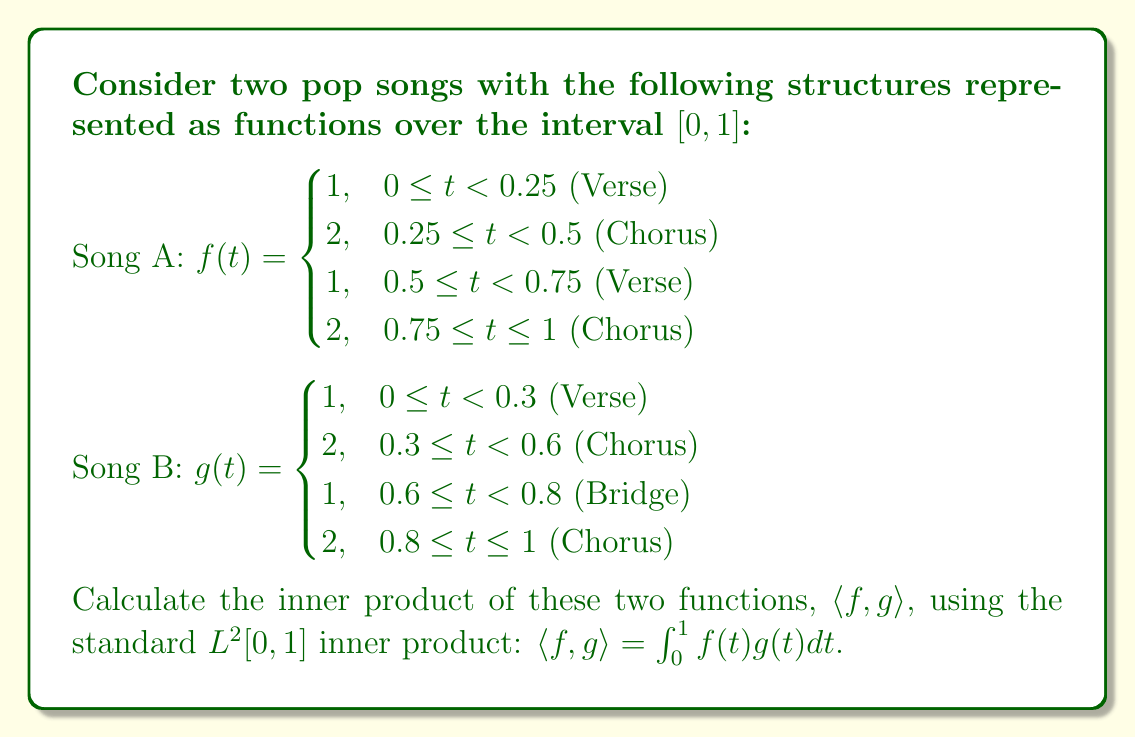Can you solve this math problem? To calculate the inner product of these two functions, we need to multiply them together and integrate over the interval $[0, 1]$. We'll break this down into segments where the functions are constant:

1) For $0 \leq t < 0.25$:
   $f(t) = 1$ and $g(t) = 1$
   $\int_0^{0.25} 1 \cdot 1 dt = 0.25$

2) For $0.25 \leq t < 0.3$:
   $f(t) = 2$ and $g(t) = 1$
   $\int_{0.25}^{0.3} 2 \cdot 1 dt = 2 \cdot 0.05 = 0.1$

3) For $0.3 \leq t < 0.5$:
   $f(t) = 2$ and $g(t) = 2$
   $\int_{0.3}^{0.5} 2 \cdot 2 dt = 4 \cdot 0.2 = 0.8$

4) For $0.5 \leq t < 0.6$:
   $f(t) = 1$ and $g(t) = 2$
   $\int_{0.5}^{0.6} 1 \cdot 2 dt = 2 \cdot 0.1 = 0.2$

5) For $0.6 \leq t < 0.75$:
   $f(t) = 1$ and $g(t) = 1$
   $\int_{0.6}^{0.75} 1 \cdot 1 dt = 0.15$

6) For $0.75 \leq t < 0.8$:
   $f(t) = 2$ and $g(t) = 1$
   $\int_{0.75}^{0.8} 2 \cdot 1 dt = 2 \cdot 0.05 = 0.1$

7) For $0.8 \leq t \leq 1$:
   $f(t) = 2$ and $g(t) = 2$
   $\int_{0.8}^1 2 \cdot 2 dt = 4 \cdot 0.2 = 0.8$

Now, we sum all these integrals:

$\langle f, g \rangle = 0.25 + 0.1 + 0.8 + 0.2 + 0.15 + 0.1 + 0.8 = 2.4$
Answer: $\langle f, g \rangle = 2.4$ 